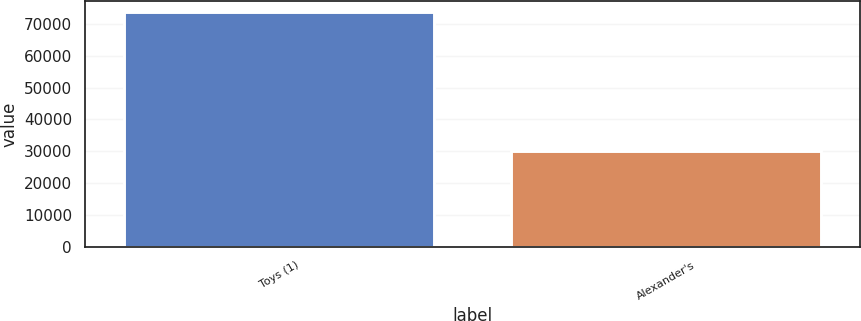Convert chart to OTSL. <chart><loc_0><loc_0><loc_500><loc_500><bar_chart><fcel>Toys (1)<fcel>Alexander's<nl><fcel>73556<fcel>30009<nl></chart> 